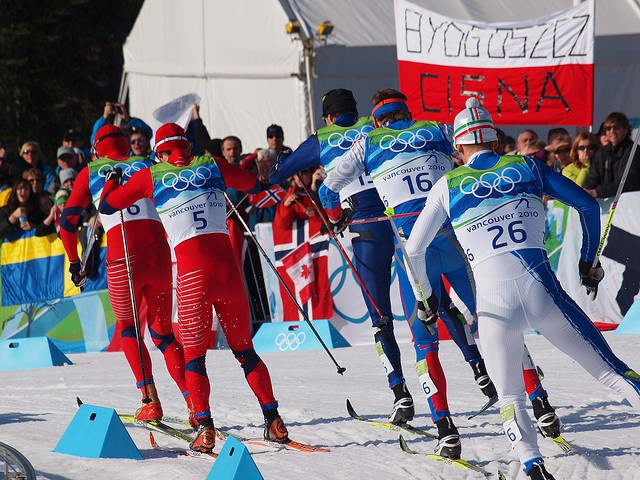Describe the objects in this image and their specific colors. I can see people in black, lightgray, darkgray, navy, and gray tones, people in black, maroon, and brown tones, people in black, maroon, and brown tones, people in black, navy, lightgray, and blue tones, and people in black, navy, lavender, and blue tones in this image. 